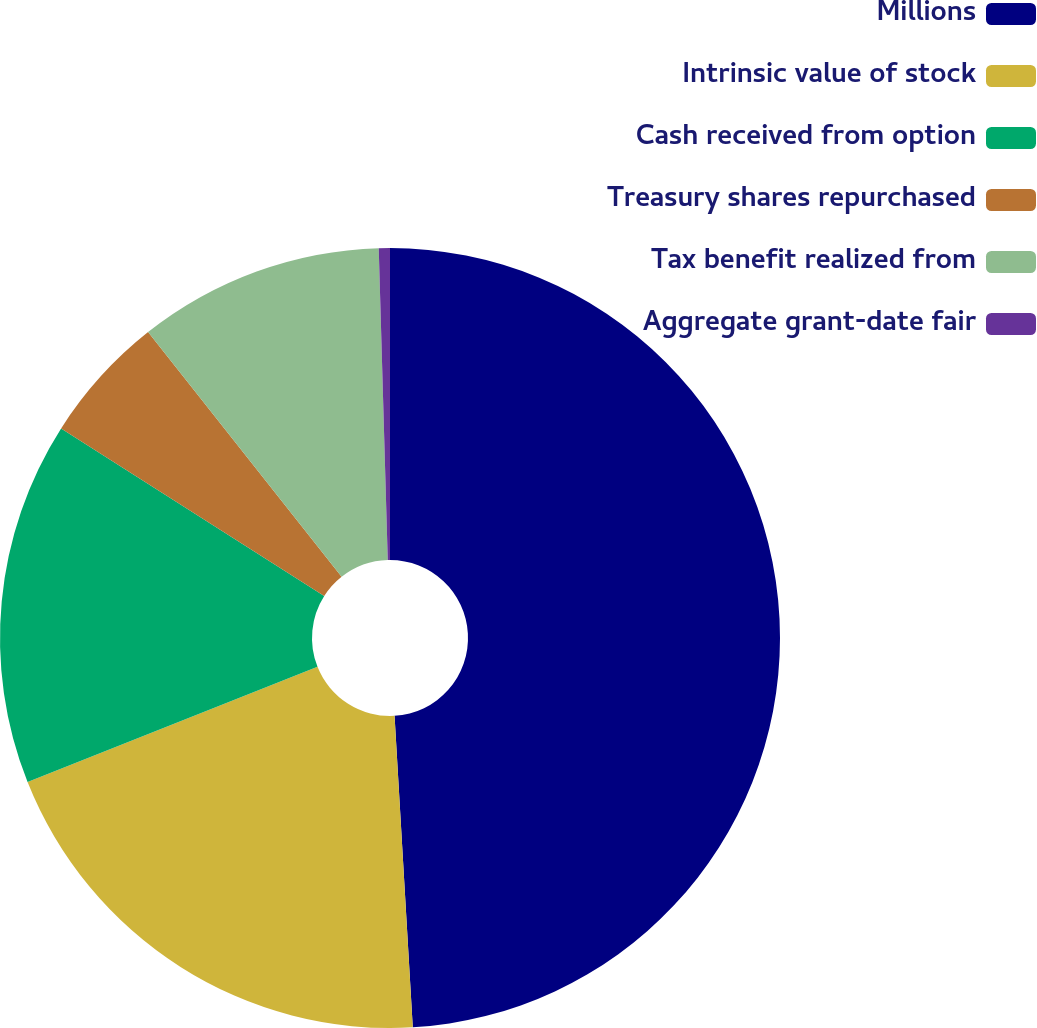Convert chart to OTSL. <chart><loc_0><loc_0><loc_500><loc_500><pie_chart><fcel>Millions<fcel>Intrinsic value of stock<fcel>Cash received from option<fcel>Treasury shares repurchased<fcel>Tax benefit realized from<fcel>Aggregate grant-date fair<nl><fcel>49.07%<fcel>19.91%<fcel>15.05%<fcel>5.32%<fcel>10.19%<fcel>0.46%<nl></chart> 